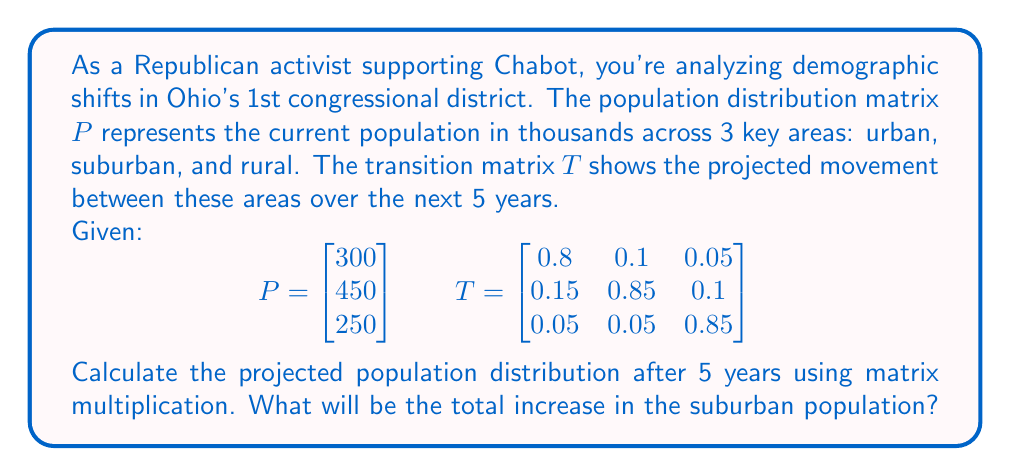Solve this math problem. To solve this problem, we need to follow these steps:

1) The projected population after 5 years is given by $T^5 \cdot P$.

2) First, let's calculate $T^5$:
   $$T^5 = \begin{bmatrix} 0.4437 & 0.3245 & 0.2318 \\ 0.3773 & 0.4615 & 0.1612 \\ 0.1790 & 0.2140 & 0.6070 \end{bmatrix}$$

3) Now, let's multiply $T^5$ by $P$:
   $$T^5 \cdot P = \begin{bmatrix} 0.4437 & 0.3245 & 0.2318 \\ 0.3773 & 0.4615 & 0.1612 \\ 0.1790 & 0.2140 & 0.6070 \end{bmatrix} \cdot \begin{bmatrix} 300 \\ 450 \\ 250 \end{bmatrix}$$

4) Performing the matrix multiplication:
   $$\begin{bmatrix} (0.4437 \cdot 300) + (0.3245 \cdot 450) + (0.2318 \cdot 250) \\ (0.3773 \cdot 300) + (0.4615 \cdot 450) + (0.1612 \cdot 250) \\ (0.1790 \cdot 300) + (0.2140 \cdot 450) + (0.6070 \cdot 250) \end{bmatrix}$$

5) Simplifying:
   $$\begin{bmatrix} 133.11 + 146.025 + 57.95 \\ 113.19 + 207.675 + 40.3 \\ 53.7 + 96.3 + 151.75 \end{bmatrix} = \begin{bmatrix} 337.085 \\ 361.165 \\ 301.75 \end{bmatrix}$$

6) The suburban population (second row) after 5 years will be approximately 361,165.

7) The initial suburban population was 450,000.

8) The change in suburban population: 361,165 - 450,000 = -88,835

Therefore, there will actually be a decrease in the suburban population.
Answer: -88,835 